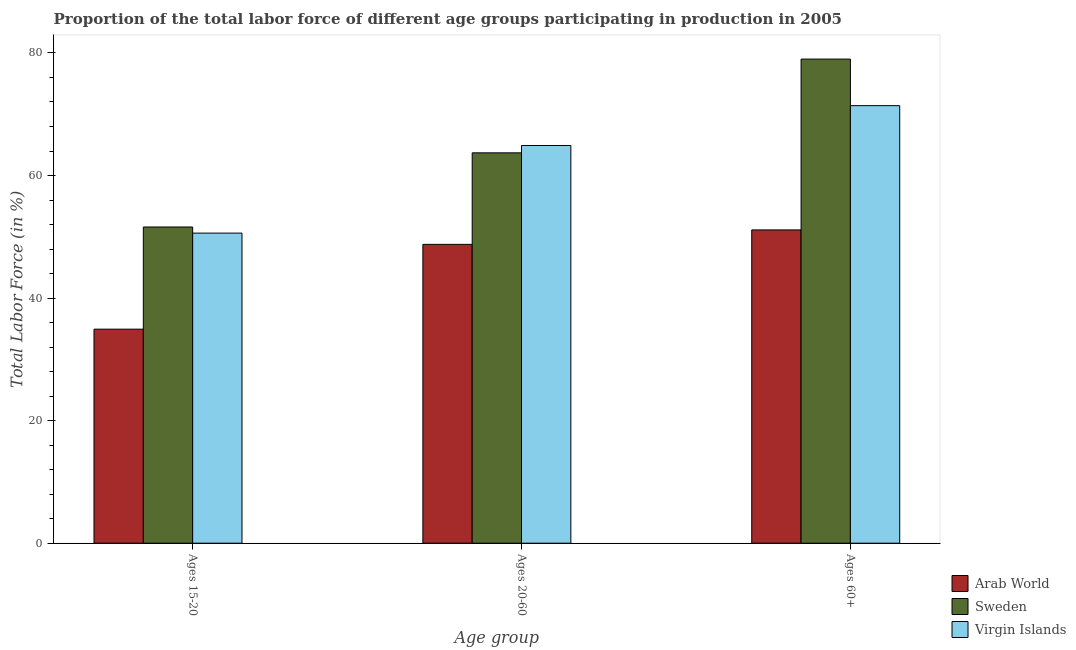Are the number of bars per tick equal to the number of legend labels?
Your answer should be compact. Yes. What is the label of the 3rd group of bars from the left?
Provide a succinct answer. Ages 60+. What is the percentage of labor force within the age group 15-20 in Sweden?
Make the answer very short. 51.6. Across all countries, what is the maximum percentage of labor force above age 60?
Offer a terse response. 79. Across all countries, what is the minimum percentage of labor force within the age group 15-20?
Offer a terse response. 34.93. In which country was the percentage of labor force within the age group 20-60 minimum?
Your response must be concise. Arab World. What is the total percentage of labor force above age 60 in the graph?
Give a very brief answer. 201.52. What is the difference between the percentage of labor force above age 60 in Sweden and that in Arab World?
Your answer should be very brief. 27.88. What is the difference between the percentage of labor force within the age group 20-60 in Sweden and the percentage of labor force within the age group 15-20 in Arab World?
Offer a terse response. 28.77. What is the average percentage of labor force above age 60 per country?
Offer a very short reply. 67.17. What is the difference between the percentage of labor force within the age group 15-20 and percentage of labor force within the age group 20-60 in Virgin Islands?
Offer a terse response. -14.3. In how many countries, is the percentage of labor force above age 60 greater than 60 %?
Keep it short and to the point. 2. What is the ratio of the percentage of labor force within the age group 15-20 in Virgin Islands to that in Sweden?
Provide a short and direct response. 0.98. Is the percentage of labor force within the age group 20-60 in Arab World less than that in Sweden?
Provide a succinct answer. Yes. What is the difference between the highest and the lowest percentage of labor force within the age group 15-20?
Offer a very short reply. 16.67. In how many countries, is the percentage of labor force within the age group 20-60 greater than the average percentage of labor force within the age group 20-60 taken over all countries?
Give a very brief answer. 2. Is the sum of the percentage of labor force within the age group 20-60 in Arab World and Virgin Islands greater than the maximum percentage of labor force above age 60 across all countries?
Provide a short and direct response. Yes. What does the 1st bar from the left in Ages 15-20 represents?
Provide a succinct answer. Arab World. What does the 3rd bar from the right in Ages 20-60 represents?
Provide a succinct answer. Arab World. Is it the case that in every country, the sum of the percentage of labor force within the age group 15-20 and percentage of labor force within the age group 20-60 is greater than the percentage of labor force above age 60?
Provide a succinct answer. Yes. Are all the bars in the graph horizontal?
Ensure brevity in your answer.  No. How many countries are there in the graph?
Keep it short and to the point. 3. What is the difference between two consecutive major ticks on the Y-axis?
Ensure brevity in your answer.  20. Does the graph contain any zero values?
Offer a terse response. No. Where does the legend appear in the graph?
Ensure brevity in your answer.  Bottom right. What is the title of the graph?
Offer a very short reply. Proportion of the total labor force of different age groups participating in production in 2005. What is the label or title of the X-axis?
Your answer should be compact. Age group. What is the label or title of the Y-axis?
Your answer should be very brief. Total Labor Force (in %). What is the Total Labor Force (in %) in Arab World in Ages 15-20?
Provide a succinct answer. 34.93. What is the Total Labor Force (in %) in Sweden in Ages 15-20?
Your answer should be very brief. 51.6. What is the Total Labor Force (in %) of Virgin Islands in Ages 15-20?
Give a very brief answer. 50.6. What is the Total Labor Force (in %) in Arab World in Ages 20-60?
Keep it short and to the point. 48.76. What is the Total Labor Force (in %) in Sweden in Ages 20-60?
Your answer should be very brief. 63.7. What is the Total Labor Force (in %) of Virgin Islands in Ages 20-60?
Offer a very short reply. 64.9. What is the Total Labor Force (in %) in Arab World in Ages 60+?
Provide a succinct answer. 51.12. What is the Total Labor Force (in %) of Sweden in Ages 60+?
Offer a very short reply. 79. What is the Total Labor Force (in %) in Virgin Islands in Ages 60+?
Offer a very short reply. 71.4. Across all Age group, what is the maximum Total Labor Force (in %) in Arab World?
Offer a very short reply. 51.12. Across all Age group, what is the maximum Total Labor Force (in %) of Sweden?
Your answer should be compact. 79. Across all Age group, what is the maximum Total Labor Force (in %) in Virgin Islands?
Offer a terse response. 71.4. Across all Age group, what is the minimum Total Labor Force (in %) in Arab World?
Ensure brevity in your answer.  34.93. Across all Age group, what is the minimum Total Labor Force (in %) of Sweden?
Offer a very short reply. 51.6. Across all Age group, what is the minimum Total Labor Force (in %) of Virgin Islands?
Make the answer very short. 50.6. What is the total Total Labor Force (in %) of Arab World in the graph?
Your response must be concise. 134.81. What is the total Total Labor Force (in %) in Sweden in the graph?
Make the answer very short. 194.3. What is the total Total Labor Force (in %) of Virgin Islands in the graph?
Offer a terse response. 186.9. What is the difference between the Total Labor Force (in %) of Arab World in Ages 15-20 and that in Ages 20-60?
Provide a short and direct response. -13.84. What is the difference between the Total Labor Force (in %) of Virgin Islands in Ages 15-20 and that in Ages 20-60?
Offer a very short reply. -14.3. What is the difference between the Total Labor Force (in %) in Arab World in Ages 15-20 and that in Ages 60+?
Keep it short and to the point. -16.2. What is the difference between the Total Labor Force (in %) of Sweden in Ages 15-20 and that in Ages 60+?
Offer a very short reply. -27.4. What is the difference between the Total Labor Force (in %) in Virgin Islands in Ages 15-20 and that in Ages 60+?
Offer a terse response. -20.8. What is the difference between the Total Labor Force (in %) in Arab World in Ages 20-60 and that in Ages 60+?
Keep it short and to the point. -2.36. What is the difference between the Total Labor Force (in %) in Sweden in Ages 20-60 and that in Ages 60+?
Make the answer very short. -15.3. What is the difference between the Total Labor Force (in %) in Arab World in Ages 15-20 and the Total Labor Force (in %) in Sweden in Ages 20-60?
Provide a succinct answer. -28.77. What is the difference between the Total Labor Force (in %) of Arab World in Ages 15-20 and the Total Labor Force (in %) of Virgin Islands in Ages 20-60?
Give a very brief answer. -29.97. What is the difference between the Total Labor Force (in %) of Sweden in Ages 15-20 and the Total Labor Force (in %) of Virgin Islands in Ages 20-60?
Your response must be concise. -13.3. What is the difference between the Total Labor Force (in %) in Arab World in Ages 15-20 and the Total Labor Force (in %) in Sweden in Ages 60+?
Provide a short and direct response. -44.07. What is the difference between the Total Labor Force (in %) in Arab World in Ages 15-20 and the Total Labor Force (in %) in Virgin Islands in Ages 60+?
Keep it short and to the point. -36.47. What is the difference between the Total Labor Force (in %) in Sweden in Ages 15-20 and the Total Labor Force (in %) in Virgin Islands in Ages 60+?
Offer a terse response. -19.8. What is the difference between the Total Labor Force (in %) in Arab World in Ages 20-60 and the Total Labor Force (in %) in Sweden in Ages 60+?
Your answer should be compact. -30.24. What is the difference between the Total Labor Force (in %) of Arab World in Ages 20-60 and the Total Labor Force (in %) of Virgin Islands in Ages 60+?
Your answer should be compact. -22.64. What is the difference between the Total Labor Force (in %) of Sweden in Ages 20-60 and the Total Labor Force (in %) of Virgin Islands in Ages 60+?
Give a very brief answer. -7.7. What is the average Total Labor Force (in %) of Arab World per Age group?
Offer a terse response. 44.94. What is the average Total Labor Force (in %) of Sweden per Age group?
Your answer should be compact. 64.77. What is the average Total Labor Force (in %) in Virgin Islands per Age group?
Offer a terse response. 62.3. What is the difference between the Total Labor Force (in %) of Arab World and Total Labor Force (in %) of Sweden in Ages 15-20?
Give a very brief answer. -16.67. What is the difference between the Total Labor Force (in %) of Arab World and Total Labor Force (in %) of Virgin Islands in Ages 15-20?
Ensure brevity in your answer.  -15.67. What is the difference between the Total Labor Force (in %) of Sweden and Total Labor Force (in %) of Virgin Islands in Ages 15-20?
Ensure brevity in your answer.  1. What is the difference between the Total Labor Force (in %) in Arab World and Total Labor Force (in %) in Sweden in Ages 20-60?
Your answer should be compact. -14.94. What is the difference between the Total Labor Force (in %) of Arab World and Total Labor Force (in %) of Virgin Islands in Ages 20-60?
Offer a very short reply. -16.14. What is the difference between the Total Labor Force (in %) in Arab World and Total Labor Force (in %) in Sweden in Ages 60+?
Your response must be concise. -27.88. What is the difference between the Total Labor Force (in %) of Arab World and Total Labor Force (in %) of Virgin Islands in Ages 60+?
Your answer should be compact. -20.28. What is the difference between the Total Labor Force (in %) of Sweden and Total Labor Force (in %) of Virgin Islands in Ages 60+?
Your answer should be very brief. 7.6. What is the ratio of the Total Labor Force (in %) in Arab World in Ages 15-20 to that in Ages 20-60?
Provide a short and direct response. 0.72. What is the ratio of the Total Labor Force (in %) of Sweden in Ages 15-20 to that in Ages 20-60?
Keep it short and to the point. 0.81. What is the ratio of the Total Labor Force (in %) of Virgin Islands in Ages 15-20 to that in Ages 20-60?
Keep it short and to the point. 0.78. What is the ratio of the Total Labor Force (in %) of Arab World in Ages 15-20 to that in Ages 60+?
Provide a short and direct response. 0.68. What is the ratio of the Total Labor Force (in %) in Sweden in Ages 15-20 to that in Ages 60+?
Give a very brief answer. 0.65. What is the ratio of the Total Labor Force (in %) in Virgin Islands in Ages 15-20 to that in Ages 60+?
Your answer should be very brief. 0.71. What is the ratio of the Total Labor Force (in %) of Arab World in Ages 20-60 to that in Ages 60+?
Your answer should be compact. 0.95. What is the ratio of the Total Labor Force (in %) of Sweden in Ages 20-60 to that in Ages 60+?
Provide a short and direct response. 0.81. What is the ratio of the Total Labor Force (in %) of Virgin Islands in Ages 20-60 to that in Ages 60+?
Offer a very short reply. 0.91. What is the difference between the highest and the second highest Total Labor Force (in %) of Arab World?
Your response must be concise. 2.36. What is the difference between the highest and the second highest Total Labor Force (in %) in Sweden?
Give a very brief answer. 15.3. What is the difference between the highest and the lowest Total Labor Force (in %) in Arab World?
Give a very brief answer. 16.2. What is the difference between the highest and the lowest Total Labor Force (in %) of Sweden?
Keep it short and to the point. 27.4. What is the difference between the highest and the lowest Total Labor Force (in %) in Virgin Islands?
Offer a very short reply. 20.8. 